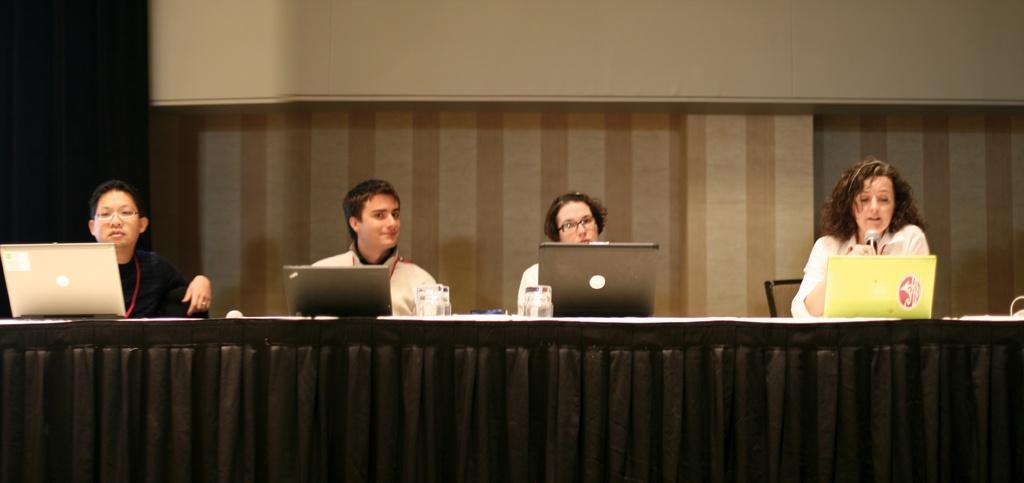Please provide a concise description of this image. In the middle of this image, there are four persons sitting in front of a table, on which there are four laptops, glasses and other objects arranged. This table is covered with a black color cloth. In the background, there is a white color sheet and a wall. 